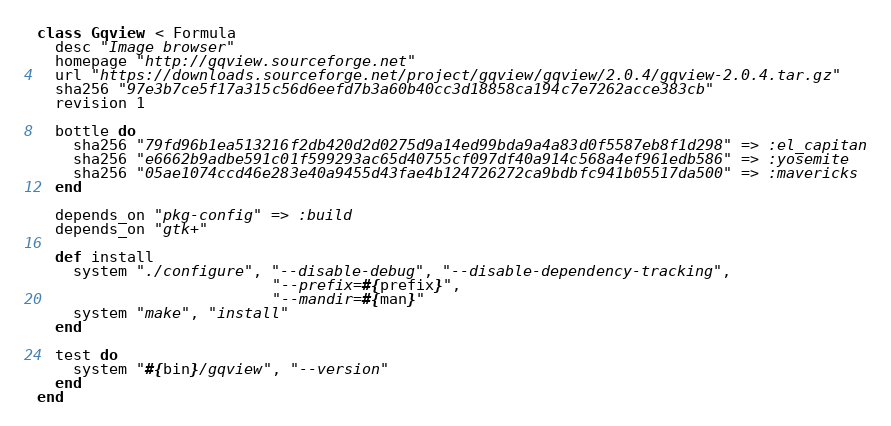<code> <loc_0><loc_0><loc_500><loc_500><_Ruby_>class Gqview < Formula
  desc "Image browser"
  homepage "http://gqview.sourceforge.net"
  url "https://downloads.sourceforge.net/project/gqview/gqview/2.0.4/gqview-2.0.4.tar.gz"
  sha256 "97e3b7ce5f17a315c56d6eefd7b3a60b40cc3d18858ca194c7e7262acce383cb"
  revision 1

  bottle do
    sha256 "79fd96b1ea513216f2db420d2d0275d9a14ed99bda9a4a83d0f5587eb8f1d298" => :el_capitan
    sha256 "e6662b9adbe591c01f599293ac65d40755cf097df40a914c568a4ef961edb586" => :yosemite
    sha256 "05ae1074ccd46e283e40a9455d43fae4b124726272ca9bdbfc941b05517da500" => :mavericks
  end

  depends_on "pkg-config" => :build
  depends_on "gtk+"

  def install
    system "./configure", "--disable-debug", "--disable-dependency-tracking",
                          "--prefix=#{prefix}",
                          "--mandir=#{man}"
    system "make", "install"
  end

  test do
    system "#{bin}/gqview", "--version"
  end
end
</code> 